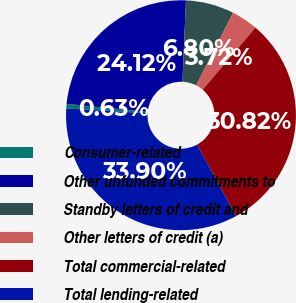Convert chart. <chart><loc_0><loc_0><loc_500><loc_500><pie_chart><fcel>Consumer-related<fcel>Other unfunded commitments to<fcel>Standby letters of credit and<fcel>Other letters of credit (a)<fcel>Total commercial-related<fcel>Total lending-related<nl><fcel>0.63%<fcel>24.12%<fcel>6.8%<fcel>3.72%<fcel>30.82%<fcel>33.9%<nl></chart> 